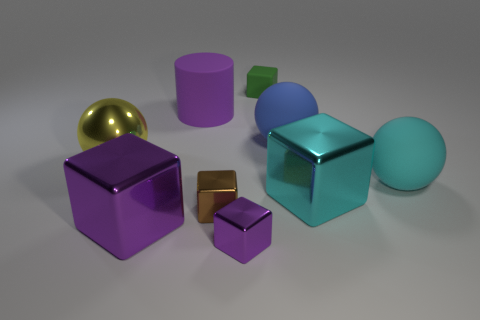Subtract all yellow blocks. Subtract all brown cylinders. How many blocks are left? 5 Subtract all cylinders. How many objects are left? 8 Subtract all matte blocks. Subtract all small gray shiny cylinders. How many objects are left? 8 Add 2 big yellow things. How many big yellow things are left? 3 Add 3 cyan metal cubes. How many cyan metal cubes exist? 4 Subtract 0 gray cylinders. How many objects are left? 9 